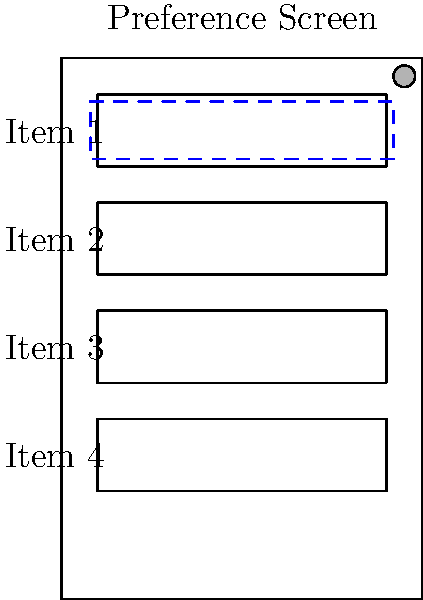When designing an accessibility-friendly preference screen layout for an Android app, which visual cue in the diagram indicates that the first preference item is currently focused by a screen reader, and what additional considerations should be implemented to enhance the user experience for visually impaired users? To design an accessibility-friendly preference screen layout, consider the following steps:

1. Visual Indication: In the diagram, the blue dashed box around the first preference item indicates that it's currently focused by a screen reader. This visual cue helps sighted users understand the screen reader's focus.

2. Content Descriptions: Ensure that each preference item has a clear and concise content description. This allows screen readers to accurately convey the purpose of each item to visually impaired users.

3. Logical Navigation: Arrange preference items in a logical order, allowing users to navigate through them easily using directional controls or gestures.

4. Grouping: Use preference categories or headers to group related items, making it easier for users to understand the structure of the settings.

5. State Changes: Implement proper state change announcements for toggles, checkboxes, or other interactive elements within the preference items.

6. Font Sizes: Allow users to adjust font sizes within the app, including the preference screen, to accommodate various visual needs.

7. Color Contrast: Ensure sufficient color contrast between text and background for better readability. The accessibility icon in the top-right corner of the diagram suggests that accessibility features are considered.

8. Touch Target Size: Make touch targets large enough (at least 48x48dp) for users with motor impairments to interact with easily.

9. Keyboard Navigation: Support keyboard navigation for users who rely on external keyboards or switch devices.

10. Testing: Regularly test the preference screen with screen readers like TalkBack to ensure a smooth experience for visually impaired users.

By implementing these considerations, you create a more inclusive and accessible preference screen layout that caters to users with various abilities.
Answer: Blue dashed focus indicator; implement content descriptions, logical navigation, proper grouping, state change announcements, adjustable font sizes, high color contrast, large touch targets, and keyboard navigation support. 